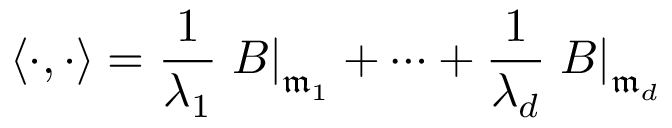<formula> <loc_0><loc_0><loc_500><loc_500>\langle \cdot , \cdot \rangle = { \frac { 1 } { \lambda _ { 1 } } } B \right | _ { { \mathfrak { m } } _ { 1 } } + \cdots + { \frac { 1 } { \lambda _ { d } } } B \right | _ { { \mathfrak { m } } _ { d } }</formula> 